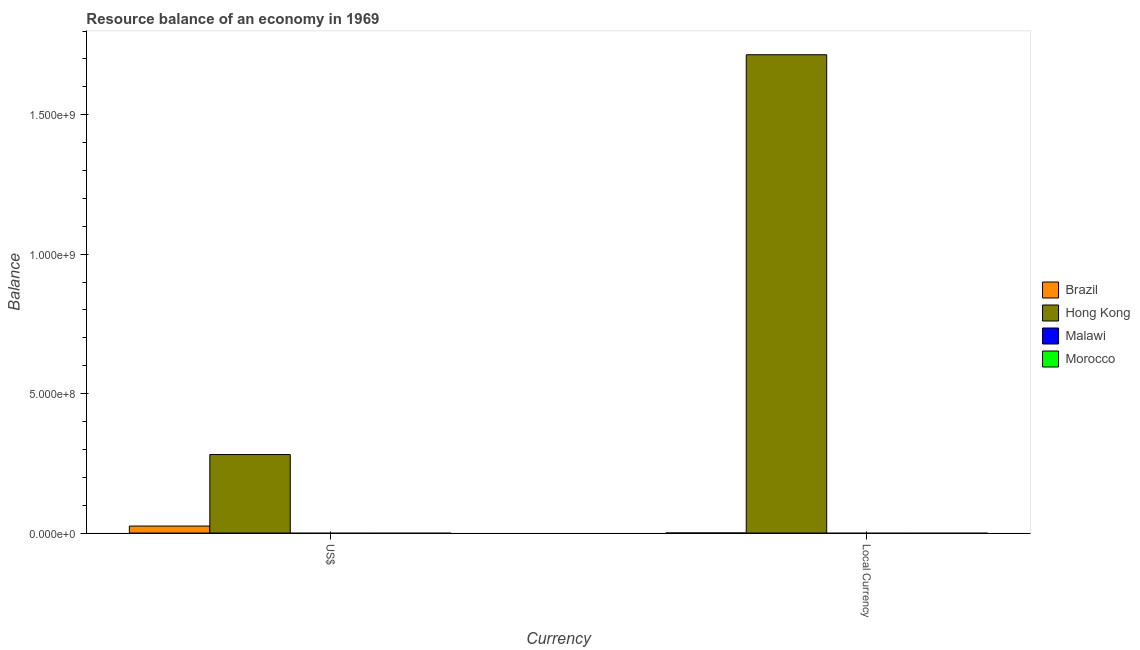How many different coloured bars are there?
Your response must be concise. 2. Are the number of bars per tick equal to the number of legend labels?
Your answer should be very brief. No. Are the number of bars on each tick of the X-axis equal?
Your answer should be very brief. Yes. How many bars are there on the 2nd tick from the right?
Offer a very short reply. 2. What is the label of the 1st group of bars from the left?
Your answer should be very brief. US$. What is the resource balance in constant us$ in Malawi?
Your response must be concise. 0. Across all countries, what is the maximum resource balance in constant us$?
Offer a very short reply. 1.72e+09. In which country was the resource balance in constant us$ maximum?
Offer a very short reply. Hong Kong. What is the total resource balance in us$ in the graph?
Keep it short and to the point. 3.06e+08. What is the average resource balance in us$ per country?
Your response must be concise. 7.66e+07. What is the difference between the resource balance in constant us$ and resource balance in us$ in Hong Kong?
Offer a terse response. 1.43e+09. In how many countries, is the resource balance in us$ greater than 1000000000 units?
Give a very brief answer. 0. What is the ratio of the resource balance in constant us$ in Hong Kong to that in Brazil?
Keep it short and to the point. 4.64e+13. In how many countries, is the resource balance in us$ greater than the average resource balance in us$ taken over all countries?
Ensure brevity in your answer.  1. Are all the bars in the graph horizontal?
Ensure brevity in your answer.  No. Does the graph contain grids?
Your answer should be compact. No. How many legend labels are there?
Provide a short and direct response. 4. How are the legend labels stacked?
Your answer should be very brief. Vertical. What is the title of the graph?
Keep it short and to the point. Resource balance of an economy in 1969. Does "Algeria" appear as one of the legend labels in the graph?
Offer a very short reply. No. What is the label or title of the X-axis?
Offer a terse response. Currency. What is the label or title of the Y-axis?
Offer a very short reply. Balance. What is the Balance of Brazil in US$?
Your response must be concise. 2.50e+07. What is the Balance in Hong Kong in US$?
Your answer should be compact. 2.81e+08. What is the Balance of Brazil in Local Currency?
Offer a terse response. 3.700000000000011e-5. What is the Balance of Hong Kong in Local Currency?
Your response must be concise. 1.72e+09. What is the Balance of Morocco in Local Currency?
Offer a terse response. 0. Across all Currency, what is the maximum Balance in Brazil?
Provide a short and direct response. 2.50e+07. Across all Currency, what is the maximum Balance in Hong Kong?
Offer a very short reply. 1.72e+09. Across all Currency, what is the minimum Balance of Brazil?
Keep it short and to the point. 3.700000000000011e-5. Across all Currency, what is the minimum Balance of Hong Kong?
Your answer should be compact. 2.81e+08. What is the total Balance in Brazil in the graph?
Provide a short and direct response. 2.50e+07. What is the total Balance in Hong Kong in the graph?
Make the answer very short. 2.00e+09. What is the total Balance of Malawi in the graph?
Your answer should be very brief. 0. What is the difference between the Balance of Brazil in US$ and that in Local Currency?
Provide a succinct answer. 2.50e+07. What is the difference between the Balance of Hong Kong in US$ and that in Local Currency?
Your answer should be very brief. -1.43e+09. What is the difference between the Balance in Brazil in US$ and the Balance in Hong Kong in Local Currency?
Give a very brief answer. -1.69e+09. What is the average Balance in Brazil per Currency?
Provide a short and direct response. 1.25e+07. What is the average Balance of Hong Kong per Currency?
Your response must be concise. 9.98e+08. What is the average Balance in Morocco per Currency?
Your answer should be compact. 0. What is the difference between the Balance in Brazil and Balance in Hong Kong in US$?
Offer a terse response. -2.56e+08. What is the difference between the Balance in Brazil and Balance in Hong Kong in Local Currency?
Provide a succinct answer. -1.72e+09. What is the ratio of the Balance in Brazil in US$ to that in Local Currency?
Your response must be concise. 6.75e+11. What is the ratio of the Balance in Hong Kong in US$ to that in Local Currency?
Offer a very short reply. 0.16. What is the difference between the highest and the second highest Balance in Brazil?
Provide a succinct answer. 2.50e+07. What is the difference between the highest and the second highest Balance of Hong Kong?
Provide a succinct answer. 1.43e+09. What is the difference between the highest and the lowest Balance of Brazil?
Provide a succinct answer. 2.50e+07. What is the difference between the highest and the lowest Balance of Hong Kong?
Make the answer very short. 1.43e+09. 